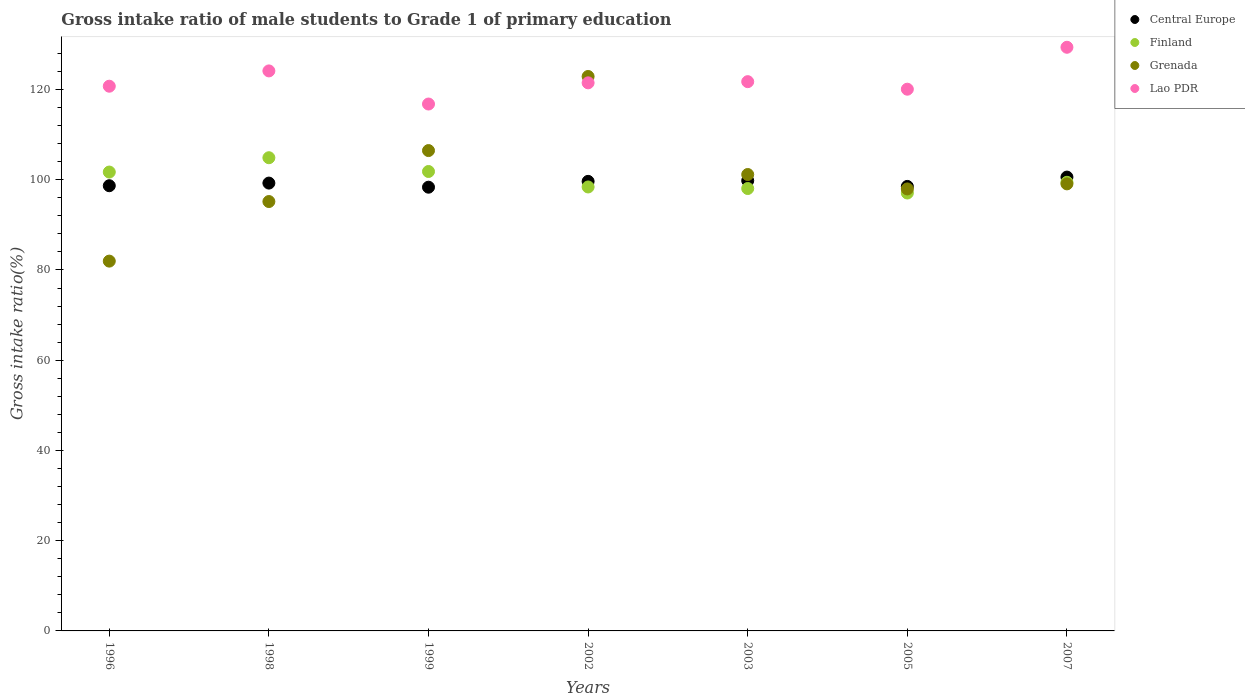How many different coloured dotlines are there?
Ensure brevity in your answer.  4. What is the gross intake ratio in Finland in 1999?
Give a very brief answer. 101.82. Across all years, what is the maximum gross intake ratio in Grenada?
Give a very brief answer. 122.88. Across all years, what is the minimum gross intake ratio in Central Europe?
Keep it short and to the point. 98.34. In which year was the gross intake ratio in Grenada minimum?
Provide a succinct answer. 1996. What is the total gross intake ratio in Grenada in the graph?
Make the answer very short. 704.66. What is the difference between the gross intake ratio in Lao PDR in 2003 and that in 2007?
Provide a succinct answer. -7.62. What is the difference between the gross intake ratio in Central Europe in 2002 and the gross intake ratio in Grenada in 2003?
Give a very brief answer. -1.52. What is the average gross intake ratio in Finland per year?
Ensure brevity in your answer.  100.19. In the year 1996, what is the difference between the gross intake ratio in Grenada and gross intake ratio in Finland?
Ensure brevity in your answer.  -19.74. In how many years, is the gross intake ratio in Lao PDR greater than 76 %?
Provide a succinct answer. 7. What is the ratio of the gross intake ratio in Central Europe in 1998 to that in 2005?
Provide a succinct answer. 1.01. What is the difference between the highest and the second highest gross intake ratio in Lao PDR?
Make the answer very short. 5.24. What is the difference between the highest and the lowest gross intake ratio in Central Europe?
Provide a succinct answer. 2.24. Is the sum of the gross intake ratio in Grenada in 1999 and 2002 greater than the maximum gross intake ratio in Central Europe across all years?
Your answer should be very brief. Yes. What is the difference between two consecutive major ticks on the Y-axis?
Provide a short and direct response. 20. Are the values on the major ticks of Y-axis written in scientific E-notation?
Provide a succinct answer. No. Where does the legend appear in the graph?
Your response must be concise. Top right. What is the title of the graph?
Keep it short and to the point. Gross intake ratio of male students to Grade 1 of primary education. What is the label or title of the Y-axis?
Your answer should be compact. Gross intake ratio(%). What is the Gross intake ratio(%) of Central Europe in 1996?
Keep it short and to the point. 98.67. What is the Gross intake ratio(%) of Finland in 1996?
Your response must be concise. 101.7. What is the Gross intake ratio(%) in Grenada in 1996?
Make the answer very short. 81.96. What is the Gross intake ratio(%) in Lao PDR in 1996?
Provide a succinct answer. 120.72. What is the Gross intake ratio(%) of Central Europe in 1998?
Your answer should be compact. 99.25. What is the Gross intake ratio(%) of Finland in 1998?
Provide a succinct answer. 104.88. What is the Gross intake ratio(%) in Grenada in 1998?
Make the answer very short. 95.16. What is the Gross intake ratio(%) in Lao PDR in 1998?
Keep it short and to the point. 124.11. What is the Gross intake ratio(%) in Central Europe in 1999?
Your answer should be very brief. 98.34. What is the Gross intake ratio(%) in Finland in 1999?
Your answer should be compact. 101.82. What is the Gross intake ratio(%) of Grenada in 1999?
Your answer should be very brief. 106.46. What is the Gross intake ratio(%) of Lao PDR in 1999?
Provide a short and direct response. 116.78. What is the Gross intake ratio(%) in Central Europe in 2002?
Make the answer very short. 99.63. What is the Gross intake ratio(%) in Finland in 2002?
Your answer should be compact. 98.39. What is the Gross intake ratio(%) of Grenada in 2002?
Give a very brief answer. 122.88. What is the Gross intake ratio(%) of Lao PDR in 2002?
Provide a succinct answer. 121.47. What is the Gross intake ratio(%) of Central Europe in 2003?
Make the answer very short. 99.79. What is the Gross intake ratio(%) of Finland in 2003?
Offer a terse response. 98.05. What is the Gross intake ratio(%) in Grenada in 2003?
Your answer should be very brief. 101.15. What is the Gross intake ratio(%) in Lao PDR in 2003?
Keep it short and to the point. 121.73. What is the Gross intake ratio(%) of Central Europe in 2005?
Your response must be concise. 98.51. What is the Gross intake ratio(%) in Finland in 2005?
Offer a terse response. 97.05. What is the Gross intake ratio(%) of Grenada in 2005?
Ensure brevity in your answer.  97.96. What is the Gross intake ratio(%) in Lao PDR in 2005?
Make the answer very short. 120.06. What is the Gross intake ratio(%) in Central Europe in 2007?
Your answer should be very brief. 100.58. What is the Gross intake ratio(%) of Finland in 2007?
Provide a short and direct response. 99.43. What is the Gross intake ratio(%) in Grenada in 2007?
Ensure brevity in your answer.  99.08. What is the Gross intake ratio(%) in Lao PDR in 2007?
Provide a succinct answer. 129.36. Across all years, what is the maximum Gross intake ratio(%) in Central Europe?
Make the answer very short. 100.58. Across all years, what is the maximum Gross intake ratio(%) of Finland?
Provide a short and direct response. 104.88. Across all years, what is the maximum Gross intake ratio(%) of Grenada?
Keep it short and to the point. 122.88. Across all years, what is the maximum Gross intake ratio(%) in Lao PDR?
Offer a very short reply. 129.36. Across all years, what is the minimum Gross intake ratio(%) of Central Europe?
Keep it short and to the point. 98.34. Across all years, what is the minimum Gross intake ratio(%) in Finland?
Ensure brevity in your answer.  97.05. Across all years, what is the minimum Gross intake ratio(%) in Grenada?
Ensure brevity in your answer.  81.96. Across all years, what is the minimum Gross intake ratio(%) in Lao PDR?
Provide a short and direct response. 116.78. What is the total Gross intake ratio(%) in Central Europe in the graph?
Offer a very short reply. 694.79. What is the total Gross intake ratio(%) of Finland in the graph?
Offer a very short reply. 701.32. What is the total Gross intake ratio(%) of Grenada in the graph?
Your answer should be very brief. 704.66. What is the total Gross intake ratio(%) of Lao PDR in the graph?
Provide a succinct answer. 854.24. What is the difference between the Gross intake ratio(%) in Central Europe in 1996 and that in 1998?
Provide a short and direct response. -0.58. What is the difference between the Gross intake ratio(%) of Finland in 1996 and that in 1998?
Offer a very short reply. -3.18. What is the difference between the Gross intake ratio(%) in Grenada in 1996 and that in 1998?
Keep it short and to the point. -13.2. What is the difference between the Gross intake ratio(%) of Lao PDR in 1996 and that in 1998?
Offer a terse response. -3.39. What is the difference between the Gross intake ratio(%) of Central Europe in 1996 and that in 1999?
Give a very brief answer. 0.33. What is the difference between the Gross intake ratio(%) in Finland in 1996 and that in 1999?
Give a very brief answer. -0.12. What is the difference between the Gross intake ratio(%) in Grenada in 1996 and that in 1999?
Ensure brevity in your answer.  -24.5. What is the difference between the Gross intake ratio(%) of Lao PDR in 1996 and that in 1999?
Offer a very short reply. 3.95. What is the difference between the Gross intake ratio(%) in Central Europe in 1996 and that in 2002?
Keep it short and to the point. -0.96. What is the difference between the Gross intake ratio(%) of Finland in 1996 and that in 2002?
Your answer should be compact. 3.3. What is the difference between the Gross intake ratio(%) in Grenada in 1996 and that in 2002?
Make the answer very short. -40.92. What is the difference between the Gross intake ratio(%) of Lao PDR in 1996 and that in 2002?
Give a very brief answer. -0.75. What is the difference between the Gross intake ratio(%) in Central Europe in 1996 and that in 2003?
Your response must be concise. -1.12. What is the difference between the Gross intake ratio(%) in Finland in 1996 and that in 2003?
Your answer should be very brief. 3.65. What is the difference between the Gross intake ratio(%) of Grenada in 1996 and that in 2003?
Offer a terse response. -19.2. What is the difference between the Gross intake ratio(%) in Lao PDR in 1996 and that in 2003?
Keep it short and to the point. -1.01. What is the difference between the Gross intake ratio(%) in Central Europe in 1996 and that in 2005?
Provide a succinct answer. 0.16. What is the difference between the Gross intake ratio(%) of Finland in 1996 and that in 2005?
Offer a terse response. 4.65. What is the difference between the Gross intake ratio(%) of Grenada in 1996 and that in 2005?
Your response must be concise. -16. What is the difference between the Gross intake ratio(%) of Lao PDR in 1996 and that in 2005?
Ensure brevity in your answer.  0.66. What is the difference between the Gross intake ratio(%) of Central Europe in 1996 and that in 2007?
Offer a terse response. -1.92. What is the difference between the Gross intake ratio(%) of Finland in 1996 and that in 2007?
Offer a very short reply. 2.27. What is the difference between the Gross intake ratio(%) of Grenada in 1996 and that in 2007?
Keep it short and to the point. -17.12. What is the difference between the Gross intake ratio(%) of Lao PDR in 1996 and that in 2007?
Your answer should be compact. -8.63. What is the difference between the Gross intake ratio(%) of Central Europe in 1998 and that in 1999?
Keep it short and to the point. 0.91. What is the difference between the Gross intake ratio(%) of Finland in 1998 and that in 1999?
Provide a short and direct response. 3.05. What is the difference between the Gross intake ratio(%) in Grenada in 1998 and that in 1999?
Make the answer very short. -11.3. What is the difference between the Gross intake ratio(%) of Lao PDR in 1998 and that in 1999?
Offer a terse response. 7.34. What is the difference between the Gross intake ratio(%) of Central Europe in 1998 and that in 2002?
Offer a very short reply. -0.38. What is the difference between the Gross intake ratio(%) in Finland in 1998 and that in 2002?
Give a very brief answer. 6.48. What is the difference between the Gross intake ratio(%) of Grenada in 1998 and that in 2002?
Give a very brief answer. -27.72. What is the difference between the Gross intake ratio(%) of Lao PDR in 1998 and that in 2002?
Provide a short and direct response. 2.64. What is the difference between the Gross intake ratio(%) of Central Europe in 1998 and that in 2003?
Offer a very short reply. -0.54. What is the difference between the Gross intake ratio(%) of Finland in 1998 and that in 2003?
Give a very brief answer. 6.83. What is the difference between the Gross intake ratio(%) of Grenada in 1998 and that in 2003?
Offer a very short reply. -5.99. What is the difference between the Gross intake ratio(%) in Lao PDR in 1998 and that in 2003?
Provide a short and direct response. 2.38. What is the difference between the Gross intake ratio(%) in Central Europe in 1998 and that in 2005?
Offer a very short reply. 0.74. What is the difference between the Gross intake ratio(%) of Finland in 1998 and that in 2005?
Your answer should be very brief. 7.82. What is the difference between the Gross intake ratio(%) in Grenada in 1998 and that in 2005?
Make the answer very short. -2.8. What is the difference between the Gross intake ratio(%) of Lao PDR in 1998 and that in 2005?
Give a very brief answer. 4.05. What is the difference between the Gross intake ratio(%) in Central Europe in 1998 and that in 2007?
Provide a succinct answer. -1.33. What is the difference between the Gross intake ratio(%) of Finland in 1998 and that in 2007?
Keep it short and to the point. 5.45. What is the difference between the Gross intake ratio(%) of Grenada in 1998 and that in 2007?
Keep it short and to the point. -3.92. What is the difference between the Gross intake ratio(%) in Lao PDR in 1998 and that in 2007?
Offer a terse response. -5.24. What is the difference between the Gross intake ratio(%) in Central Europe in 1999 and that in 2002?
Make the answer very short. -1.29. What is the difference between the Gross intake ratio(%) of Finland in 1999 and that in 2002?
Provide a succinct answer. 3.43. What is the difference between the Gross intake ratio(%) in Grenada in 1999 and that in 2002?
Your response must be concise. -16.42. What is the difference between the Gross intake ratio(%) of Lao PDR in 1999 and that in 2002?
Your answer should be very brief. -4.7. What is the difference between the Gross intake ratio(%) in Central Europe in 1999 and that in 2003?
Provide a succinct answer. -1.45. What is the difference between the Gross intake ratio(%) in Finland in 1999 and that in 2003?
Offer a very short reply. 3.77. What is the difference between the Gross intake ratio(%) in Grenada in 1999 and that in 2003?
Your answer should be compact. 5.3. What is the difference between the Gross intake ratio(%) of Lao PDR in 1999 and that in 2003?
Your answer should be compact. -4.96. What is the difference between the Gross intake ratio(%) of Central Europe in 1999 and that in 2005?
Offer a terse response. -0.17. What is the difference between the Gross intake ratio(%) in Finland in 1999 and that in 2005?
Your answer should be very brief. 4.77. What is the difference between the Gross intake ratio(%) of Grenada in 1999 and that in 2005?
Make the answer very short. 8.5. What is the difference between the Gross intake ratio(%) in Lao PDR in 1999 and that in 2005?
Make the answer very short. -3.29. What is the difference between the Gross intake ratio(%) in Central Europe in 1999 and that in 2007?
Your answer should be compact. -2.24. What is the difference between the Gross intake ratio(%) of Finland in 1999 and that in 2007?
Offer a very short reply. 2.39. What is the difference between the Gross intake ratio(%) of Grenada in 1999 and that in 2007?
Provide a short and direct response. 7.38. What is the difference between the Gross intake ratio(%) in Lao PDR in 1999 and that in 2007?
Your response must be concise. -12.58. What is the difference between the Gross intake ratio(%) in Central Europe in 2002 and that in 2003?
Give a very brief answer. -0.16. What is the difference between the Gross intake ratio(%) of Finland in 2002 and that in 2003?
Make the answer very short. 0.35. What is the difference between the Gross intake ratio(%) of Grenada in 2002 and that in 2003?
Your answer should be compact. 21.72. What is the difference between the Gross intake ratio(%) in Lao PDR in 2002 and that in 2003?
Your answer should be compact. -0.26. What is the difference between the Gross intake ratio(%) in Central Europe in 2002 and that in 2005?
Your answer should be very brief. 1.12. What is the difference between the Gross intake ratio(%) of Finland in 2002 and that in 2005?
Make the answer very short. 1.34. What is the difference between the Gross intake ratio(%) of Grenada in 2002 and that in 2005?
Provide a succinct answer. 24.92. What is the difference between the Gross intake ratio(%) in Lao PDR in 2002 and that in 2005?
Your response must be concise. 1.41. What is the difference between the Gross intake ratio(%) in Central Europe in 2002 and that in 2007?
Provide a short and direct response. -0.95. What is the difference between the Gross intake ratio(%) of Finland in 2002 and that in 2007?
Offer a terse response. -1.03. What is the difference between the Gross intake ratio(%) in Grenada in 2002 and that in 2007?
Make the answer very short. 23.8. What is the difference between the Gross intake ratio(%) of Lao PDR in 2002 and that in 2007?
Offer a terse response. -7.88. What is the difference between the Gross intake ratio(%) of Central Europe in 2003 and that in 2005?
Ensure brevity in your answer.  1.28. What is the difference between the Gross intake ratio(%) of Grenada in 2003 and that in 2005?
Keep it short and to the point. 3.2. What is the difference between the Gross intake ratio(%) of Lao PDR in 2003 and that in 2005?
Ensure brevity in your answer.  1.67. What is the difference between the Gross intake ratio(%) of Central Europe in 2003 and that in 2007?
Offer a terse response. -0.79. What is the difference between the Gross intake ratio(%) of Finland in 2003 and that in 2007?
Give a very brief answer. -1.38. What is the difference between the Gross intake ratio(%) in Grenada in 2003 and that in 2007?
Provide a succinct answer. 2.07. What is the difference between the Gross intake ratio(%) in Lao PDR in 2003 and that in 2007?
Your answer should be very brief. -7.62. What is the difference between the Gross intake ratio(%) of Central Europe in 2005 and that in 2007?
Offer a very short reply. -2.07. What is the difference between the Gross intake ratio(%) in Finland in 2005 and that in 2007?
Keep it short and to the point. -2.37. What is the difference between the Gross intake ratio(%) in Grenada in 2005 and that in 2007?
Your answer should be compact. -1.12. What is the difference between the Gross intake ratio(%) of Lao PDR in 2005 and that in 2007?
Offer a very short reply. -9.29. What is the difference between the Gross intake ratio(%) of Central Europe in 1996 and the Gross intake ratio(%) of Finland in 1998?
Make the answer very short. -6.21. What is the difference between the Gross intake ratio(%) of Central Europe in 1996 and the Gross intake ratio(%) of Grenada in 1998?
Ensure brevity in your answer.  3.51. What is the difference between the Gross intake ratio(%) of Central Europe in 1996 and the Gross intake ratio(%) of Lao PDR in 1998?
Offer a terse response. -25.45. What is the difference between the Gross intake ratio(%) in Finland in 1996 and the Gross intake ratio(%) in Grenada in 1998?
Offer a terse response. 6.54. What is the difference between the Gross intake ratio(%) of Finland in 1996 and the Gross intake ratio(%) of Lao PDR in 1998?
Keep it short and to the point. -22.42. What is the difference between the Gross intake ratio(%) of Grenada in 1996 and the Gross intake ratio(%) of Lao PDR in 1998?
Provide a succinct answer. -42.16. What is the difference between the Gross intake ratio(%) in Central Europe in 1996 and the Gross intake ratio(%) in Finland in 1999?
Give a very brief answer. -3.15. What is the difference between the Gross intake ratio(%) in Central Europe in 1996 and the Gross intake ratio(%) in Grenada in 1999?
Offer a very short reply. -7.79. What is the difference between the Gross intake ratio(%) of Central Europe in 1996 and the Gross intake ratio(%) of Lao PDR in 1999?
Provide a short and direct response. -18.11. What is the difference between the Gross intake ratio(%) of Finland in 1996 and the Gross intake ratio(%) of Grenada in 1999?
Your response must be concise. -4.76. What is the difference between the Gross intake ratio(%) of Finland in 1996 and the Gross intake ratio(%) of Lao PDR in 1999?
Offer a terse response. -15.08. What is the difference between the Gross intake ratio(%) in Grenada in 1996 and the Gross intake ratio(%) in Lao PDR in 1999?
Make the answer very short. -34.82. What is the difference between the Gross intake ratio(%) in Central Europe in 1996 and the Gross intake ratio(%) in Finland in 2002?
Your answer should be very brief. 0.28. What is the difference between the Gross intake ratio(%) of Central Europe in 1996 and the Gross intake ratio(%) of Grenada in 2002?
Your answer should be very brief. -24.21. What is the difference between the Gross intake ratio(%) in Central Europe in 1996 and the Gross intake ratio(%) in Lao PDR in 2002?
Provide a short and direct response. -22.8. What is the difference between the Gross intake ratio(%) of Finland in 1996 and the Gross intake ratio(%) of Grenada in 2002?
Provide a succinct answer. -21.18. What is the difference between the Gross intake ratio(%) in Finland in 1996 and the Gross intake ratio(%) in Lao PDR in 2002?
Ensure brevity in your answer.  -19.77. What is the difference between the Gross intake ratio(%) of Grenada in 1996 and the Gross intake ratio(%) of Lao PDR in 2002?
Your answer should be very brief. -39.51. What is the difference between the Gross intake ratio(%) in Central Europe in 1996 and the Gross intake ratio(%) in Finland in 2003?
Provide a succinct answer. 0.62. What is the difference between the Gross intake ratio(%) in Central Europe in 1996 and the Gross intake ratio(%) in Grenada in 2003?
Your answer should be compact. -2.49. What is the difference between the Gross intake ratio(%) of Central Europe in 1996 and the Gross intake ratio(%) of Lao PDR in 2003?
Give a very brief answer. -23.06. What is the difference between the Gross intake ratio(%) in Finland in 1996 and the Gross intake ratio(%) in Grenada in 2003?
Give a very brief answer. 0.54. What is the difference between the Gross intake ratio(%) in Finland in 1996 and the Gross intake ratio(%) in Lao PDR in 2003?
Give a very brief answer. -20.03. What is the difference between the Gross intake ratio(%) of Grenada in 1996 and the Gross intake ratio(%) of Lao PDR in 2003?
Your answer should be compact. -39.77. What is the difference between the Gross intake ratio(%) in Central Europe in 1996 and the Gross intake ratio(%) in Finland in 2005?
Provide a short and direct response. 1.62. What is the difference between the Gross intake ratio(%) of Central Europe in 1996 and the Gross intake ratio(%) of Grenada in 2005?
Your response must be concise. 0.71. What is the difference between the Gross intake ratio(%) in Central Europe in 1996 and the Gross intake ratio(%) in Lao PDR in 2005?
Your answer should be very brief. -21.39. What is the difference between the Gross intake ratio(%) of Finland in 1996 and the Gross intake ratio(%) of Grenada in 2005?
Keep it short and to the point. 3.74. What is the difference between the Gross intake ratio(%) of Finland in 1996 and the Gross intake ratio(%) of Lao PDR in 2005?
Provide a short and direct response. -18.36. What is the difference between the Gross intake ratio(%) in Grenada in 1996 and the Gross intake ratio(%) in Lao PDR in 2005?
Provide a succinct answer. -38.1. What is the difference between the Gross intake ratio(%) of Central Europe in 1996 and the Gross intake ratio(%) of Finland in 2007?
Make the answer very short. -0.76. What is the difference between the Gross intake ratio(%) of Central Europe in 1996 and the Gross intake ratio(%) of Grenada in 2007?
Offer a very short reply. -0.41. What is the difference between the Gross intake ratio(%) of Central Europe in 1996 and the Gross intake ratio(%) of Lao PDR in 2007?
Your answer should be compact. -30.69. What is the difference between the Gross intake ratio(%) in Finland in 1996 and the Gross intake ratio(%) in Grenada in 2007?
Ensure brevity in your answer.  2.62. What is the difference between the Gross intake ratio(%) of Finland in 1996 and the Gross intake ratio(%) of Lao PDR in 2007?
Offer a very short reply. -27.66. What is the difference between the Gross intake ratio(%) of Grenada in 1996 and the Gross intake ratio(%) of Lao PDR in 2007?
Keep it short and to the point. -47.4. What is the difference between the Gross intake ratio(%) of Central Europe in 1998 and the Gross intake ratio(%) of Finland in 1999?
Your response must be concise. -2.57. What is the difference between the Gross intake ratio(%) in Central Europe in 1998 and the Gross intake ratio(%) in Grenada in 1999?
Your answer should be very brief. -7.21. What is the difference between the Gross intake ratio(%) in Central Europe in 1998 and the Gross intake ratio(%) in Lao PDR in 1999?
Offer a very short reply. -17.52. What is the difference between the Gross intake ratio(%) of Finland in 1998 and the Gross intake ratio(%) of Grenada in 1999?
Keep it short and to the point. -1.58. What is the difference between the Gross intake ratio(%) in Finland in 1998 and the Gross intake ratio(%) in Lao PDR in 1999?
Provide a succinct answer. -11.9. What is the difference between the Gross intake ratio(%) in Grenada in 1998 and the Gross intake ratio(%) in Lao PDR in 1999?
Offer a very short reply. -21.61. What is the difference between the Gross intake ratio(%) in Central Europe in 1998 and the Gross intake ratio(%) in Finland in 2002?
Make the answer very short. 0.86. What is the difference between the Gross intake ratio(%) in Central Europe in 1998 and the Gross intake ratio(%) in Grenada in 2002?
Provide a succinct answer. -23.63. What is the difference between the Gross intake ratio(%) in Central Europe in 1998 and the Gross intake ratio(%) in Lao PDR in 2002?
Your answer should be very brief. -22.22. What is the difference between the Gross intake ratio(%) in Finland in 1998 and the Gross intake ratio(%) in Grenada in 2002?
Your answer should be compact. -18. What is the difference between the Gross intake ratio(%) of Finland in 1998 and the Gross intake ratio(%) of Lao PDR in 2002?
Offer a very short reply. -16.6. What is the difference between the Gross intake ratio(%) in Grenada in 1998 and the Gross intake ratio(%) in Lao PDR in 2002?
Keep it short and to the point. -26.31. What is the difference between the Gross intake ratio(%) of Central Europe in 1998 and the Gross intake ratio(%) of Finland in 2003?
Make the answer very short. 1.2. What is the difference between the Gross intake ratio(%) in Central Europe in 1998 and the Gross intake ratio(%) in Grenada in 2003?
Make the answer very short. -1.9. What is the difference between the Gross intake ratio(%) in Central Europe in 1998 and the Gross intake ratio(%) in Lao PDR in 2003?
Give a very brief answer. -22.48. What is the difference between the Gross intake ratio(%) in Finland in 1998 and the Gross intake ratio(%) in Grenada in 2003?
Your answer should be very brief. 3.72. What is the difference between the Gross intake ratio(%) in Finland in 1998 and the Gross intake ratio(%) in Lao PDR in 2003?
Make the answer very short. -16.86. What is the difference between the Gross intake ratio(%) of Grenada in 1998 and the Gross intake ratio(%) of Lao PDR in 2003?
Make the answer very short. -26.57. What is the difference between the Gross intake ratio(%) of Central Europe in 1998 and the Gross intake ratio(%) of Finland in 2005?
Offer a terse response. 2.2. What is the difference between the Gross intake ratio(%) in Central Europe in 1998 and the Gross intake ratio(%) in Grenada in 2005?
Make the answer very short. 1.29. What is the difference between the Gross intake ratio(%) in Central Europe in 1998 and the Gross intake ratio(%) in Lao PDR in 2005?
Keep it short and to the point. -20.81. What is the difference between the Gross intake ratio(%) of Finland in 1998 and the Gross intake ratio(%) of Grenada in 2005?
Your answer should be very brief. 6.92. What is the difference between the Gross intake ratio(%) of Finland in 1998 and the Gross intake ratio(%) of Lao PDR in 2005?
Give a very brief answer. -15.19. What is the difference between the Gross intake ratio(%) of Grenada in 1998 and the Gross intake ratio(%) of Lao PDR in 2005?
Make the answer very short. -24.9. What is the difference between the Gross intake ratio(%) of Central Europe in 1998 and the Gross intake ratio(%) of Finland in 2007?
Your response must be concise. -0.17. What is the difference between the Gross intake ratio(%) of Central Europe in 1998 and the Gross intake ratio(%) of Grenada in 2007?
Make the answer very short. 0.17. What is the difference between the Gross intake ratio(%) in Central Europe in 1998 and the Gross intake ratio(%) in Lao PDR in 2007?
Provide a succinct answer. -30.1. What is the difference between the Gross intake ratio(%) in Finland in 1998 and the Gross intake ratio(%) in Grenada in 2007?
Provide a succinct answer. 5.79. What is the difference between the Gross intake ratio(%) in Finland in 1998 and the Gross intake ratio(%) in Lao PDR in 2007?
Give a very brief answer. -24.48. What is the difference between the Gross intake ratio(%) of Grenada in 1998 and the Gross intake ratio(%) of Lao PDR in 2007?
Your answer should be very brief. -34.19. What is the difference between the Gross intake ratio(%) in Central Europe in 1999 and the Gross intake ratio(%) in Finland in 2002?
Offer a terse response. -0.05. What is the difference between the Gross intake ratio(%) of Central Europe in 1999 and the Gross intake ratio(%) of Grenada in 2002?
Your answer should be very brief. -24.54. What is the difference between the Gross intake ratio(%) of Central Europe in 1999 and the Gross intake ratio(%) of Lao PDR in 2002?
Make the answer very short. -23.13. What is the difference between the Gross intake ratio(%) in Finland in 1999 and the Gross intake ratio(%) in Grenada in 2002?
Ensure brevity in your answer.  -21.06. What is the difference between the Gross intake ratio(%) of Finland in 1999 and the Gross intake ratio(%) of Lao PDR in 2002?
Make the answer very short. -19.65. What is the difference between the Gross intake ratio(%) of Grenada in 1999 and the Gross intake ratio(%) of Lao PDR in 2002?
Your answer should be compact. -15.01. What is the difference between the Gross intake ratio(%) of Central Europe in 1999 and the Gross intake ratio(%) of Finland in 2003?
Give a very brief answer. 0.3. What is the difference between the Gross intake ratio(%) in Central Europe in 1999 and the Gross intake ratio(%) in Grenada in 2003?
Provide a short and direct response. -2.81. What is the difference between the Gross intake ratio(%) in Central Europe in 1999 and the Gross intake ratio(%) in Lao PDR in 2003?
Provide a short and direct response. -23.39. What is the difference between the Gross intake ratio(%) in Finland in 1999 and the Gross intake ratio(%) in Grenada in 2003?
Your response must be concise. 0.67. What is the difference between the Gross intake ratio(%) of Finland in 1999 and the Gross intake ratio(%) of Lao PDR in 2003?
Give a very brief answer. -19.91. What is the difference between the Gross intake ratio(%) in Grenada in 1999 and the Gross intake ratio(%) in Lao PDR in 2003?
Keep it short and to the point. -15.27. What is the difference between the Gross intake ratio(%) of Central Europe in 1999 and the Gross intake ratio(%) of Finland in 2005?
Make the answer very short. 1.29. What is the difference between the Gross intake ratio(%) of Central Europe in 1999 and the Gross intake ratio(%) of Grenada in 2005?
Keep it short and to the point. 0.38. What is the difference between the Gross intake ratio(%) of Central Europe in 1999 and the Gross intake ratio(%) of Lao PDR in 2005?
Offer a terse response. -21.72. What is the difference between the Gross intake ratio(%) of Finland in 1999 and the Gross intake ratio(%) of Grenada in 2005?
Your response must be concise. 3.86. What is the difference between the Gross intake ratio(%) of Finland in 1999 and the Gross intake ratio(%) of Lao PDR in 2005?
Your answer should be very brief. -18.24. What is the difference between the Gross intake ratio(%) of Grenada in 1999 and the Gross intake ratio(%) of Lao PDR in 2005?
Offer a very short reply. -13.6. What is the difference between the Gross intake ratio(%) in Central Europe in 1999 and the Gross intake ratio(%) in Finland in 2007?
Offer a terse response. -1.08. What is the difference between the Gross intake ratio(%) of Central Europe in 1999 and the Gross intake ratio(%) of Grenada in 2007?
Ensure brevity in your answer.  -0.74. What is the difference between the Gross intake ratio(%) in Central Europe in 1999 and the Gross intake ratio(%) in Lao PDR in 2007?
Make the answer very short. -31.01. What is the difference between the Gross intake ratio(%) in Finland in 1999 and the Gross intake ratio(%) in Grenada in 2007?
Keep it short and to the point. 2.74. What is the difference between the Gross intake ratio(%) of Finland in 1999 and the Gross intake ratio(%) of Lao PDR in 2007?
Make the answer very short. -27.53. What is the difference between the Gross intake ratio(%) in Grenada in 1999 and the Gross intake ratio(%) in Lao PDR in 2007?
Give a very brief answer. -22.9. What is the difference between the Gross intake ratio(%) of Central Europe in 2002 and the Gross intake ratio(%) of Finland in 2003?
Offer a terse response. 1.59. What is the difference between the Gross intake ratio(%) of Central Europe in 2002 and the Gross intake ratio(%) of Grenada in 2003?
Your answer should be very brief. -1.52. What is the difference between the Gross intake ratio(%) of Central Europe in 2002 and the Gross intake ratio(%) of Lao PDR in 2003?
Your response must be concise. -22.1. What is the difference between the Gross intake ratio(%) of Finland in 2002 and the Gross intake ratio(%) of Grenada in 2003?
Offer a terse response. -2.76. What is the difference between the Gross intake ratio(%) of Finland in 2002 and the Gross intake ratio(%) of Lao PDR in 2003?
Offer a very short reply. -23.34. What is the difference between the Gross intake ratio(%) of Grenada in 2002 and the Gross intake ratio(%) of Lao PDR in 2003?
Offer a very short reply. 1.15. What is the difference between the Gross intake ratio(%) in Central Europe in 2002 and the Gross intake ratio(%) in Finland in 2005?
Offer a very short reply. 2.58. What is the difference between the Gross intake ratio(%) in Central Europe in 2002 and the Gross intake ratio(%) in Grenada in 2005?
Make the answer very short. 1.68. What is the difference between the Gross intake ratio(%) of Central Europe in 2002 and the Gross intake ratio(%) of Lao PDR in 2005?
Your answer should be compact. -20.43. What is the difference between the Gross intake ratio(%) of Finland in 2002 and the Gross intake ratio(%) of Grenada in 2005?
Keep it short and to the point. 0.44. What is the difference between the Gross intake ratio(%) of Finland in 2002 and the Gross intake ratio(%) of Lao PDR in 2005?
Offer a very short reply. -21.67. What is the difference between the Gross intake ratio(%) of Grenada in 2002 and the Gross intake ratio(%) of Lao PDR in 2005?
Ensure brevity in your answer.  2.82. What is the difference between the Gross intake ratio(%) of Central Europe in 2002 and the Gross intake ratio(%) of Finland in 2007?
Provide a succinct answer. 0.21. What is the difference between the Gross intake ratio(%) of Central Europe in 2002 and the Gross intake ratio(%) of Grenada in 2007?
Ensure brevity in your answer.  0.55. What is the difference between the Gross intake ratio(%) of Central Europe in 2002 and the Gross intake ratio(%) of Lao PDR in 2007?
Your answer should be compact. -29.72. What is the difference between the Gross intake ratio(%) in Finland in 2002 and the Gross intake ratio(%) in Grenada in 2007?
Offer a terse response. -0.69. What is the difference between the Gross intake ratio(%) in Finland in 2002 and the Gross intake ratio(%) in Lao PDR in 2007?
Your response must be concise. -30.96. What is the difference between the Gross intake ratio(%) in Grenada in 2002 and the Gross intake ratio(%) in Lao PDR in 2007?
Your answer should be compact. -6.48. What is the difference between the Gross intake ratio(%) in Central Europe in 2003 and the Gross intake ratio(%) in Finland in 2005?
Offer a very short reply. 2.74. What is the difference between the Gross intake ratio(%) of Central Europe in 2003 and the Gross intake ratio(%) of Grenada in 2005?
Make the answer very short. 1.83. What is the difference between the Gross intake ratio(%) of Central Europe in 2003 and the Gross intake ratio(%) of Lao PDR in 2005?
Provide a succinct answer. -20.27. What is the difference between the Gross intake ratio(%) in Finland in 2003 and the Gross intake ratio(%) in Grenada in 2005?
Offer a terse response. 0.09. What is the difference between the Gross intake ratio(%) of Finland in 2003 and the Gross intake ratio(%) of Lao PDR in 2005?
Offer a terse response. -22.01. What is the difference between the Gross intake ratio(%) of Grenada in 2003 and the Gross intake ratio(%) of Lao PDR in 2005?
Your answer should be compact. -18.91. What is the difference between the Gross intake ratio(%) of Central Europe in 2003 and the Gross intake ratio(%) of Finland in 2007?
Give a very brief answer. 0.37. What is the difference between the Gross intake ratio(%) in Central Europe in 2003 and the Gross intake ratio(%) in Grenada in 2007?
Give a very brief answer. 0.71. What is the difference between the Gross intake ratio(%) in Central Europe in 2003 and the Gross intake ratio(%) in Lao PDR in 2007?
Make the answer very short. -29.56. What is the difference between the Gross intake ratio(%) of Finland in 2003 and the Gross intake ratio(%) of Grenada in 2007?
Ensure brevity in your answer.  -1.03. What is the difference between the Gross intake ratio(%) of Finland in 2003 and the Gross intake ratio(%) of Lao PDR in 2007?
Offer a very short reply. -31.31. What is the difference between the Gross intake ratio(%) in Grenada in 2003 and the Gross intake ratio(%) in Lao PDR in 2007?
Your response must be concise. -28.2. What is the difference between the Gross intake ratio(%) of Central Europe in 2005 and the Gross intake ratio(%) of Finland in 2007?
Provide a short and direct response. -0.91. What is the difference between the Gross intake ratio(%) in Central Europe in 2005 and the Gross intake ratio(%) in Grenada in 2007?
Give a very brief answer. -0.57. What is the difference between the Gross intake ratio(%) in Central Europe in 2005 and the Gross intake ratio(%) in Lao PDR in 2007?
Provide a succinct answer. -30.84. What is the difference between the Gross intake ratio(%) in Finland in 2005 and the Gross intake ratio(%) in Grenada in 2007?
Make the answer very short. -2.03. What is the difference between the Gross intake ratio(%) in Finland in 2005 and the Gross intake ratio(%) in Lao PDR in 2007?
Offer a terse response. -32.3. What is the difference between the Gross intake ratio(%) in Grenada in 2005 and the Gross intake ratio(%) in Lao PDR in 2007?
Provide a short and direct response. -31.4. What is the average Gross intake ratio(%) of Central Europe per year?
Keep it short and to the point. 99.26. What is the average Gross intake ratio(%) in Finland per year?
Keep it short and to the point. 100.19. What is the average Gross intake ratio(%) of Grenada per year?
Your response must be concise. 100.67. What is the average Gross intake ratio(%) in Lao PDR per year?
Provide a succinct answer. 122.03. In the year 1996, what is the difference between the Gross intake ratio(%) of Central Europe and Gross intake ratio(%) of Finland?
Your response must be concise. -3.03. In the year 1996, what is the difference between the Gross intake ratio(%) of Central Europe and Gross intake ratio(%) of Grenada?
Your answer should be very brief. 16.71. In the year 1996, what is the difference between the Gross intake ratio(%) in Central Europe and Gross intake ratio(%) in Lao PDR?
Your answer should be very brief. -22.05. In the year 1996, what is the difference between the Gross intake ratio(%) in Finland and Gross intake ratio(%) in Grenada?
Ensure brevity in your answer.  19.74. In the year 1996, what is the difference between the Gross intake ratio(%) of Finland and Gross intake ratio(%) of Lao PDR?
Provide a short and direct response. -19.02. In the year 1996, what is the difference between the Gross intake ratio(%) in Grenada and Gross intake ratio(%) in Lao PDR?
Provide a succinct answer. -38.76. In the year 1998, what is the difference between the Gross intake ratio(%) in Central Europe and Gross intake ratio(%) in Finland?
Ensure brevity in your answer.  -5.62. In the year 1998, what is the difference between the Gross intake ratio(%) of Central Europe and Gross intake ratio(%) of Grenada?
Give a very brief answer. 4.09. In the year 1998, what is the difference between the Gross intake ratio(%) of Central Europe and Gross intake ratio(%) of Lao PDR?
Keep it short and to the point. -24.86. In the year 1998, what is the difference between the Gross intake ratio(%) of Finland and Gross intake ratio(%) of Grenada?
Provide a succinct answer. 9.71. In the year 1998, what is the difference between the Gross intake ratio(%) in Finland and Gross intake ratio(%) in Lao PDR?
Ensure brevity in your answer.  -19.24. In the year 1998, what is the difference between the Gross intake ratio(%) in Grenada and Gross intake ratio(%) in Lao PDR?
Make the answer very short. -28.95. In the year 1999, what is the difference between the Gross intake ratio(%) in Central Europe and Gross intake ratio(%) in Finland?
Make the answer very short. -3.48. In the year 1999, what is the difference between the Gross intake ratio(%) of Central Europe and Gross intake ratio(%) of Grenada?
Your answer should be very brief. -8.12. In the year 1999, what is the difference between the Gross intake ratio(%) of Central Europe and Gross intake ratio(%) of Lao PDR?
Make the answer very short. -18.43. In the year 1999, what is the difference between the Gross intake ratio(%) in Finland and Gross intake ratio(%) in Grenada?
Your response must be concise. -4.64. In the year 1999, what is the difference between the Gross intake ratio(%) in Finland and Gross intake ratio(%) in Lao PDR?
Your response must be concise. -14.95. In the year 1999, what is the difference between the Gross intake ratio(%) in Grenada and Gross intake ratio(%) in Lao PDR?
Your answer should be very brief. -10.32. In the year 2002, what is the difference between the Gross intake ratio(%) of Central Europe and Gross intake ratio(%) of Finland?
Provide a short and direct response. 1.24. In the year 2002, what is the difference between the Gross intake ratio(%) of Central Europe and Gross intake ratio(%) of Grenada?
Your answer should be very brief. -23.24. In the year 2002, what is the difference between the Gross intake ratio(%) of Central Europe and Gross intake ratio(%) of Lao PDR?
Make the answer very short. -21.84. In the year 2002, what is the difference between the Gross intake ratio(%) of Finland and Gross intake ratio(%) of Grenada?
Your answer should be very brief. -24.48. In the year 2002, what is the difference between the Gross intake ratio(%) in Finland and Gross intake ratio(%) in Lao PDR?
Keep it short and to the point. -23.08. In the year 2002, what is the difference between the Gross intake ratio(%) in Grenada and Gross intake ratio(%) in Lao PDR?
Provide a short and direct response. 1.41. In the year 2003, what is the difference between the Gross intake ratio(%) of Central Europe and Gross intake ratio(%) of Finland?
Give a very brief answer. 1.75. In the year 2003, what is the difference between the Gross intake ratio(%) of Central Europe and Gross intake ratio(%) of Grenada?
Provide a succinct answer. -1.36. In the year 2003, what is the difference between the Gross intake ratio(%) in Central Europe and Gross intake ratio(%) in Lao PDR?
Offer a very short reply. -21.94. In the year 2003, what is the difference between the Gross intake ratio(%) in Finland and Gross intake ratio(%) in Grenada?
Your answer should be compact. -3.11. In the year 2003, what is the difference between the Gross intake ratio(%) of Finland and Gross intake ratio(%) of Lao PDR?
Offer a very short reply. -23.68. In the year 2003, what is the difference between the Gross intake ratio(%) of Grenada and Gross intake ratio(%) of Lao PDR?
Offer a terse response. -20.58. In the year 2005, what is the difference between the Gross intake ratio(%) in Central Europe and Gross intake ratio(%) in Finland?
Your response must be concise. 1.46. In the year 2005, what is the difference between the Gross intake ratio(%) in Central Europe and Gross intake ratio(%) in Grenada?
Make the answer very short. 0.55. In the year 2005, what is the difference between the Gross intake ratio(%) in Central Europe and Gross intake ratio(%) in Lao PDR?
Offer a very short reply. -21.55. In the year 2005, what is the difference between the Gross intake ratio(%) in Finland and Gross intake ratio(%) in Grenada?
Your answer should be very brief. -0.91. In the year 2005, what is the difference between the Gross intake ratio(%) of Finland and Gross intake ratio(%) of Lao PDR?
Offer a terse response. -23.01. In the year 2005, what is the difference between the Gross intake ratio(%) in Grenada and Gross intake ratio(%) in Lao PDR?
Provide a succinct answer. -22.1. In the year 2007, what is the difference between the Gross intake ratio(%) of Central Europe and Gross intake ratio(%) of Finland?
Provide a short and direct response. 1.16. In the year 2007, what is the difference between the Gross intake ratio(%) of Central Europe and Gross intake ratio(%) of Grenada?
Offer a very short reply. 1.5. In the year 2007, what is the difference between the Gross intake ratio(%) in Central Europe and Gross intake ratio(%) in Lao PDR?
Offer a terse response. -28.77. In the year 2007, what is the difference between the Gross intake ratio(%) of Finland and Gross intake ratio(%) of Grenada?
Ensure brevity in your answer.  0.35. In the year 2007, what is the difference between the Gross intake ratio(%) in Finland and Gross intake ratio(%) in Lao PDR?
Keep it short and to the point. -29.93. In the year 2007, what is the difference between the Gross intake ratio(%) of Grenada and Gross intake ratio(%) of Lao PDR?
Your answer should be compact. -30.27. What is the ratio of the Gross intake ratio(%) of Finland in 1996 to that in 1998?
Make the answer very short. 0.97. What is the ratio of the Gross intake ratio(%) of Grenada in 1996 to that in 1998?
Your answer should be very brief. 0.86. What is the ratio of the Gross intake ratio(%) in Lao PDR in 1996 to that in 1998?
Ensure brevity in your answer.  0.97. What is the ratio of the Gross intake ratio(%) in Central Europe in 1996 to that in 1999?
Make the answer very short. 1. What is the ratio of the Gross intake ratio(%) in Finland in 1996 to that in 1999?
Give a very brief answer. 1. What is the ratio of the Gross intake ratio(%) in Grenada in 1996 to that in 1999?
Provide a short and direct response. 0.77. What is the ratio of the Gross intake ratio(%) in Lao PDR in 1996 to that in 1999?
Your answer should be compact. 1.03. What is the ratio of the Gross intake ratio(%) of Central Europe in 1996 to that in 2002?
Provide a succinct answer. 0.99. What is the ratio of the Gross intake ratio(%) of Finland in 1996 to that in 2002?
Your response must be concise. 1.03. What is the ratio of the Gross intake ratio(%) of Grenada in 1996 to that in 2002?
Give a very brief answer. 0.67. What is the ratio of the Gross intake ratio(%) in Central Europe in 1996 to that in 2003?
Offer a terse response. 0.99. What is the ratio of the Gross intake ratio(%) of Finland in 1996 to that in 2003?
Provide a short and direct response. 1.04. What is the ratio of the Gross intake ratio(%) of Grenada in 1996 to that in 2003?
Provide a succinct answer. 0.81. What is the ratio of the Gross intake ratio(%) of Lao PDR in 1996 to that in 2003?
Make the answer very short. 0.99. What is the ratio of the Gross intake ratio(%) in Finland in 1996 to that in 2005?
Give a very brief answer. 1.05. What is the ratio of the Gross intake ratio(%) in Grenada in 1996 to that in 2005?
Provide a succinct answer. 0.84. What is the ratio of the Gross intake ratio(%) of Finland in 1996 to that in 2007?
Offer a terse response. 1.02. What is the ratio of the Gross intake ratio(%) of Grenada in 1996 to that in 2007?
Provide a succinct answer. 0.83. What is the ratio of the Gross intake ratio(%) of Lao PDR in 1996 to that in 2007?
Ensure brevity in your answer.  0.93. What is the ratio of the Gross intake ratio(%) in Central Europe in 1998 to that in 1999?
Provide a short and direct response. 1.01. What is the ratio of the Gross intake ratio(%) of Grenada in 1998 to that in 1999?
Your answer should be very brief. 0.89. What is the ratio of the Gross intake ratio(%) in Lao PDR in 1998 to that in 1999?
Your answer should be very brief. 1.06. What is the ratio of the Gross intake ratio(%) in Finland in 1998 to that in 2002?
Your answer should be compact. 1.07. What is the ratio of the Gross intake ratio(%) in Grenada in 1998 to that in 2002?
Offer a very short reply. 0.77. What is the ratio of the Gross intake ratio(%) in Lao PDR in 1998 to that in 2002?
Make the answer very short. 1.02. What is the ratio of the Gross intake ratio(%) in Finland in 1998 to that in 2003?
Your answer should be very brief. 1.07. What is the ratio of the Gross intake ratio(%) in Grenada in 1998 to that in 2003?
Give a very brief answer. 0.94. What is the ratio of the Gross intake ratio(%) in Lao PDR in 1998 to that in 2003?
Ensure brevity in your answer.  1.02. What is the ratio of the Gross intake ratio(%) of Central Europe in 1998 to that in 2005?
Ensure brevity in your answer.  1.01. What is the ratio of the Gross intake ratio(%) in Finland in 1998 to that in 2005?
Your response must be concise. 1.08. What is the ratio of the Gross intake ratio(%) of Grenada in 1998 to that in 2005?
Offer a very short reply. 0.97. What is the ratio of the Gross intake ratio(%) in Lao PDR in 1998 to that in 2005?
Your answer should be compact. 1.03. What is the ratio of the Gross intake ratio(%) of Central Europe in 1998 to that in 2007?
Your answer should be compact. 0.99. What is the ratio of the Gross intake ratio(%) of Finland in 1998 to that in 2007?
Your response must be concise. 1.05. What is the ratio of the Gross intake ratio(%) of Grenada in 1998 to that in 2007?
Ensure brevity in your answer.  0.96. What is the ratio of the Gross intake ratio(%) in Lao PDR in 1998 to that in 2007?
Ensure brevity in your answer.  0.96. What is the ratio of the Gross intake ratio(%) of Finland in 1999 to that in 2002?
Make the answer very short. 1.03. What is the ratio of the Gross intake ratio(%) of Grenada in 1999 to that in 2002?
Your answer should be compact. 0.87. What is the ratio of the Gross intake ratio(%) in Lao PDR in 1999 to that in 2002?
Your answer should be compact. 0.96. What is the ratio of the Gross intake ratio(%) in Central Europe in 1999 to that in 2003?
Offer a terse response. 0.99. What is the ratio of the Gross intake ratio(%) of Finland in 1999 to that in 2003?
Your answer should be compact. 1.04. What is the ratio of the Gross intake ratio(%) in Grenada in 1999 to that in 2003?
Your response must be concise. 1.05. What is the ratio of the Gross intake ratio(%) in Lao PDR in 1999 to that in 2003?
Make the answer very short. 0.96. What is the ratio of the Gross intake ratio(%) in Central Europe in 1999 to that in 2005?
Offer a terse response. 1. What is the ratio of the Gross intake ratio(%) in Finland in 1999 to that in 2005?
Make the answer very short. 1.05. What is the ratio of the Gross intake ratio(%) of Grenada in 1999 to that in 2005?
Ensure brevity in your answer.  1.09. What is the ratio of the Gross intake ratio(%) of Lao PDR in 1999 to that in 2005?
Your response must be concise. 0.97. What is the ratio of the Gross intake ratio(%) of Central Europe in 1999 to that in 2007?
Keep it short and to the point. 0.98. What is the ratio of the Gross intake ratio(%) of Finland in 1999 to that in 2007?
Provide a succinct answer. 1.02. What is the ratio of the Gross intake ratio(%) of Grenada in 1999 to that in 2007?
Offer a very short reply. 1.07. What is the ratio of the Gross intake ratio(%) of Lao PDR in 1999 to that in 2007?
Make the answer very short. 0.9. What is the ratio of the Gross intake ratio(%) of Grenada in 2002 to that in 2003?
Your answer should be compact. 1.21. What is the ratio of the Gross intake ratio(%) in Lao PDR in 2002 to that in 2003?
Keep it short and to the point. 1. What is the ratio of the Gross intake ratio(%) of Central Europe in 2002 to that in 2005?
Your answer should be compact. 1.01. What is the ratio of the Gross intake ratio(%) in Finland in 2002 to that in 2005?
Provide a short and direct response. 1.01. What is the ratio of the Gross intake ratio(%) of Grenada in 2002 to that in 2005?
Make the answer very short. 1.25. What is the ratio of the Gross intake ratio(%) of Lao PDR in 2002 to that in 2005?
Make the answer very short. 1.01. What is the ratio of the Gross intake ratio(%) in Central Europe in 2002 to that in 2007?
Your answer should be very brief. 0.99. What is the ratio of the Gross intake ratio(%) in Grenada in 2002 to that in 2007?
Offer a terse response. 1.24. What is the ratio of the Gross intake ratio(%) of Lao PDR in 2002 to that in 2007?
Offer a terse response. 0.94. What is the ratio of the Gross intake ratio(%) in Central Europe in 2003 to that in 2005?
Your answer should be compact. 1.01. What is the ratio of the Gross intake ratio(%) of Finland in 2003 to that in 2005?
Your answer should be very brief. 1.01. What is the ratio of the Gross intake ratio(%) of Grenada in 2003 to that in 2005?
Give a very brief answer. 1.03. What is the ratio of the Gross intake ratio(%) of Lao PDR in 2003 to that in 2005?
Offer a very short reply. 1.01. What is the ratio of the Gross intake ratio(%) in Central Europe in 2003 to that in 2007?
Provide a short and direct response. 0.99. What is the ratio of the Gross intake ratio(%) in Finland in 2003 to that in 2007?
Offer a terse response. 0.99. What is the ratio of the Gross intake ratio(%) of Grenada in 2003 to that in 2007?
Offer a terse response. 1.02. What is the ratio of the Gross intake ratio(%) in Lao PDR in 2003 to that in 2007?
Ensure brevity in your answer.  0.94. What is the ratio of the Gross intake ratio(%) in Central Europe in 2005 to that in 2007?
Offer a terse response. 0.98. What is the ratio of the Gross intake ratio(%) of Finland in 2005 to that in 2007?
Offer a terse response. 0.98. What is the ratio of the Gross intake ratio(%) in Grenada in 2005 to that in 2007?
Give a very brief answer. 0.99. What is the ratio of the Gross intake ratio(%) of Lao PDR in 2005 to that in 2007?
Provide a succinct answer. 0.93. What is the difference between the highest and the second highest Gross intake ratio(%) in Central Europe?
Provide a succinct answer. 0.79. What is the difference between the highest and the second highest Gross intake ratio(%) of Finland?
Make the answer very short. 3.05. What is the difference between the highest and the second highest Gross intake ratio(%) in Grenada?
Make the answer very short. 16.42. What is the difference between the highest and the second highest Gross intake ratio(%) of Lao PDR?
Offer a terse response. 5.24. What is the difference between the highest and the lowest Gross intake ratio(%) of Central Europe?
Offer a terse response. 2.24. What is the difference between the highest and the lowest Gross intake ratio(%) in Finland?
Your answer should be very brief. 7.82. What is the difference between the highest and the lowest Gross intake ratio(%) in Grenada?
Offer a very short reply. 40.92. What is the difference between the highest and the lowest Gross intake ratio(%) in Lao PDR?
Offer a terse response. 12.58. 